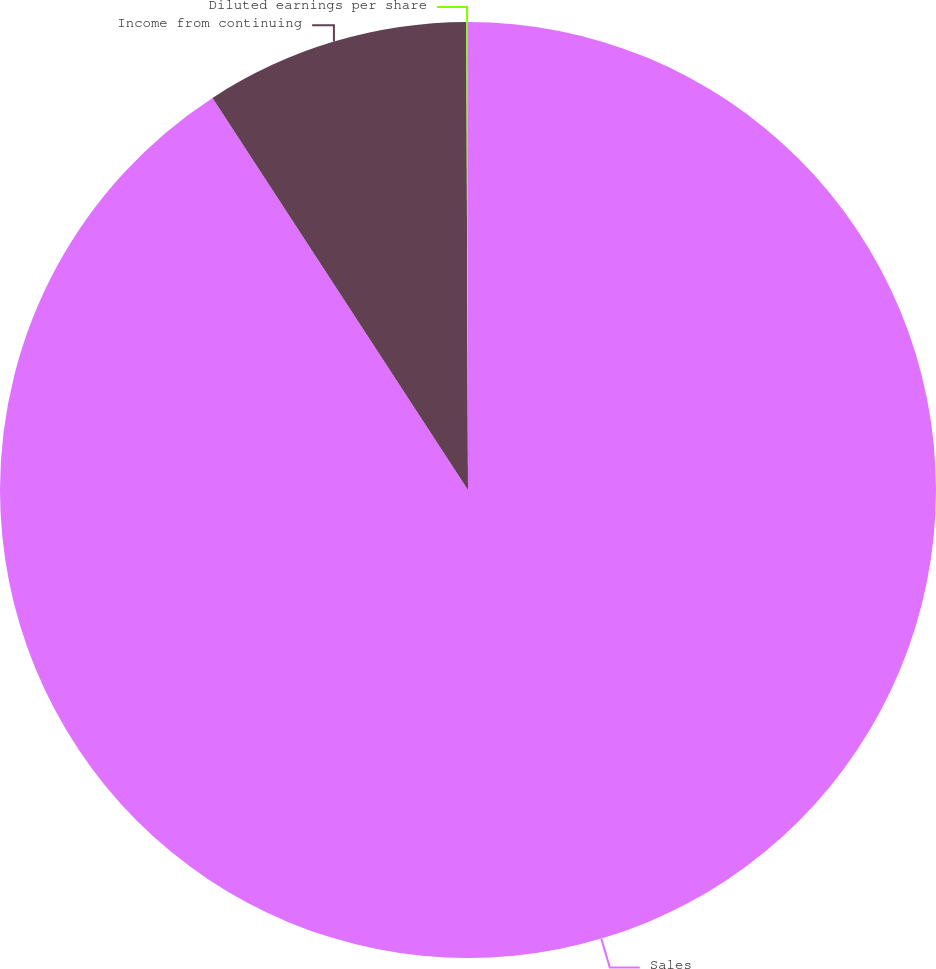Convert chart. <chart><loc_0><loc_0><loc_500><loc_500><pie_chart><fcel>Sales<fcel>Income from continuing<fcel>Diluted earnings per share<nl><fcel>90.81%<fcel>9.13%<fcel>0.06%<nl></chart> 